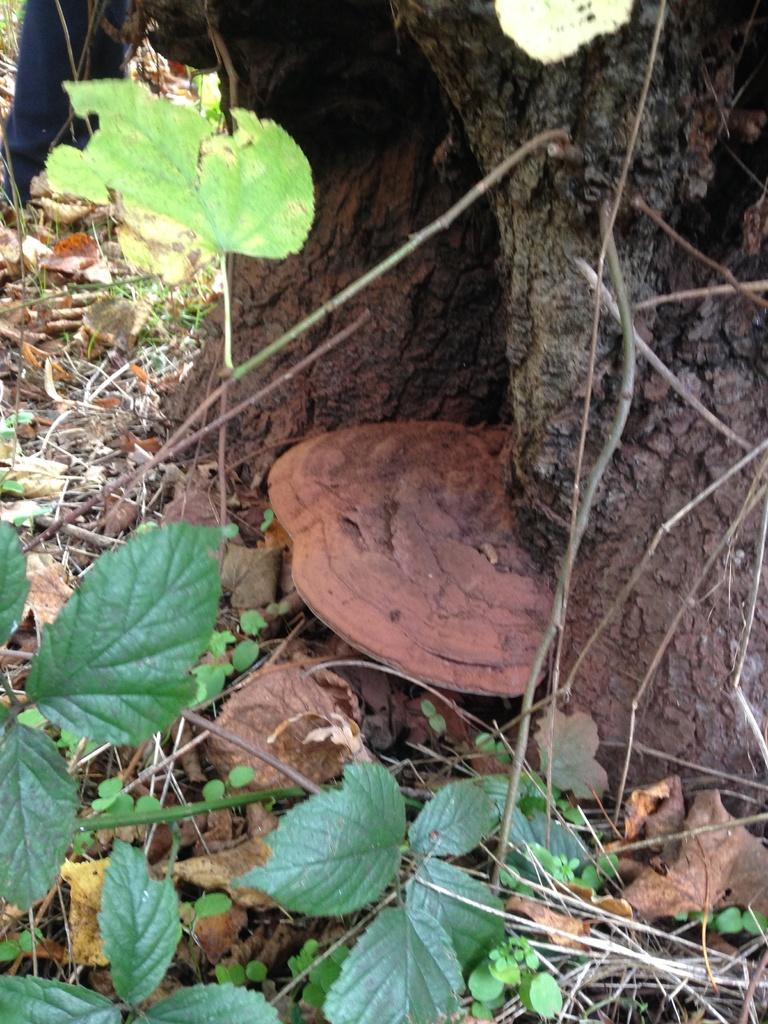What type of natural element can be seen in the image? There is a tree in the image. What else is present in the image besides the tree? There is an object and plants at the bottom of the image. What can be found at the bottom of the image along with the plants? Dried leaves and sticks are visible at the bottom of the image. What type of toy can be seen in the image? There is no toy present in the image. Is there an arch visible in the image? There is no arch present in the image. 